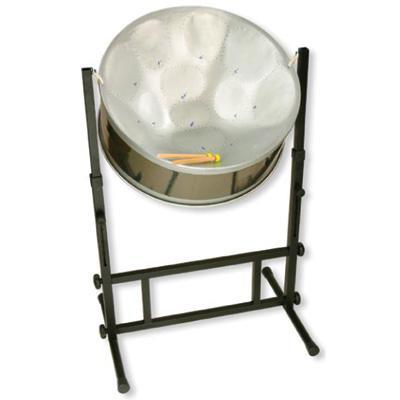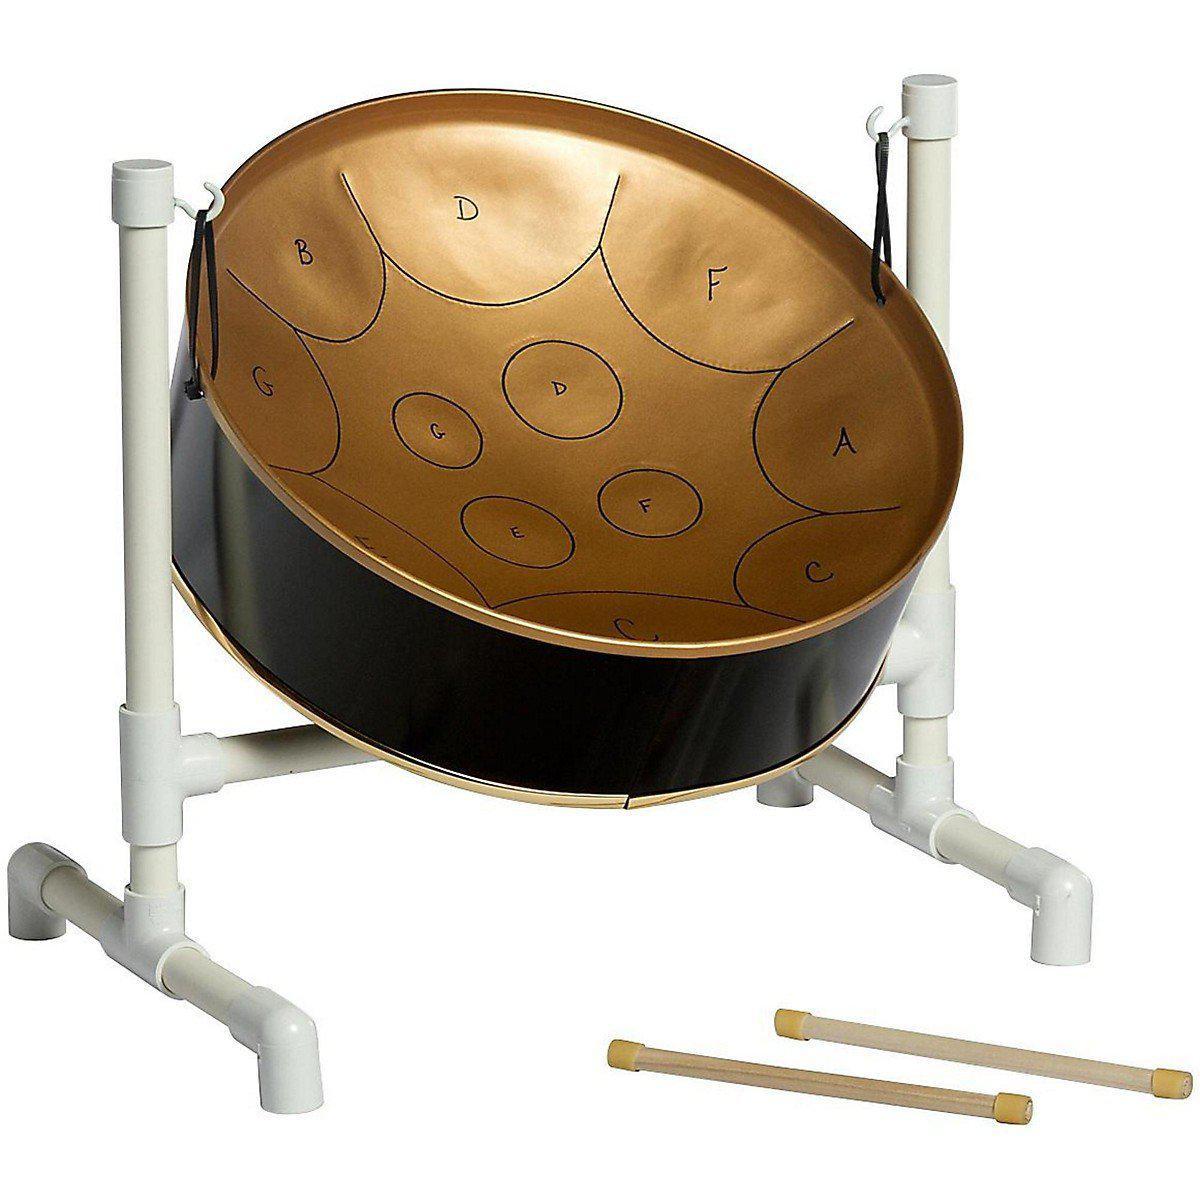The first image is the image on the left, the second image is the image on the right. Analyze the images presented: Is the assertion "The designs of two steel drums are different, as are their stands, but each has two sticks resting in the drum." valid? Answer yes or no. No. The first image is the image on the left, the second image is the image on the right. Examine the images to the left and right. Is the description "The right image contains a single chrome metal drum with two drum sticks resting on top of the drum." accurate? Answer yes or no. No. 